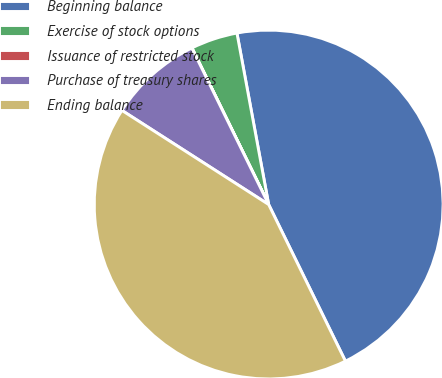Convert chart. <chart><loc_0><loc_0><loc_500><loc_500><pie_chart><fcel>Beginning balance<fcel>Exercise of stock options<fcel>Issuance of restricted stock<fcel>Purchase of treasury shares<fcel>Ending balance<nl><fcel>45.66%<fcel>4.34%<fcel>0.01%<fcel>8.66%<fcel>41.33%<nl></chart> 